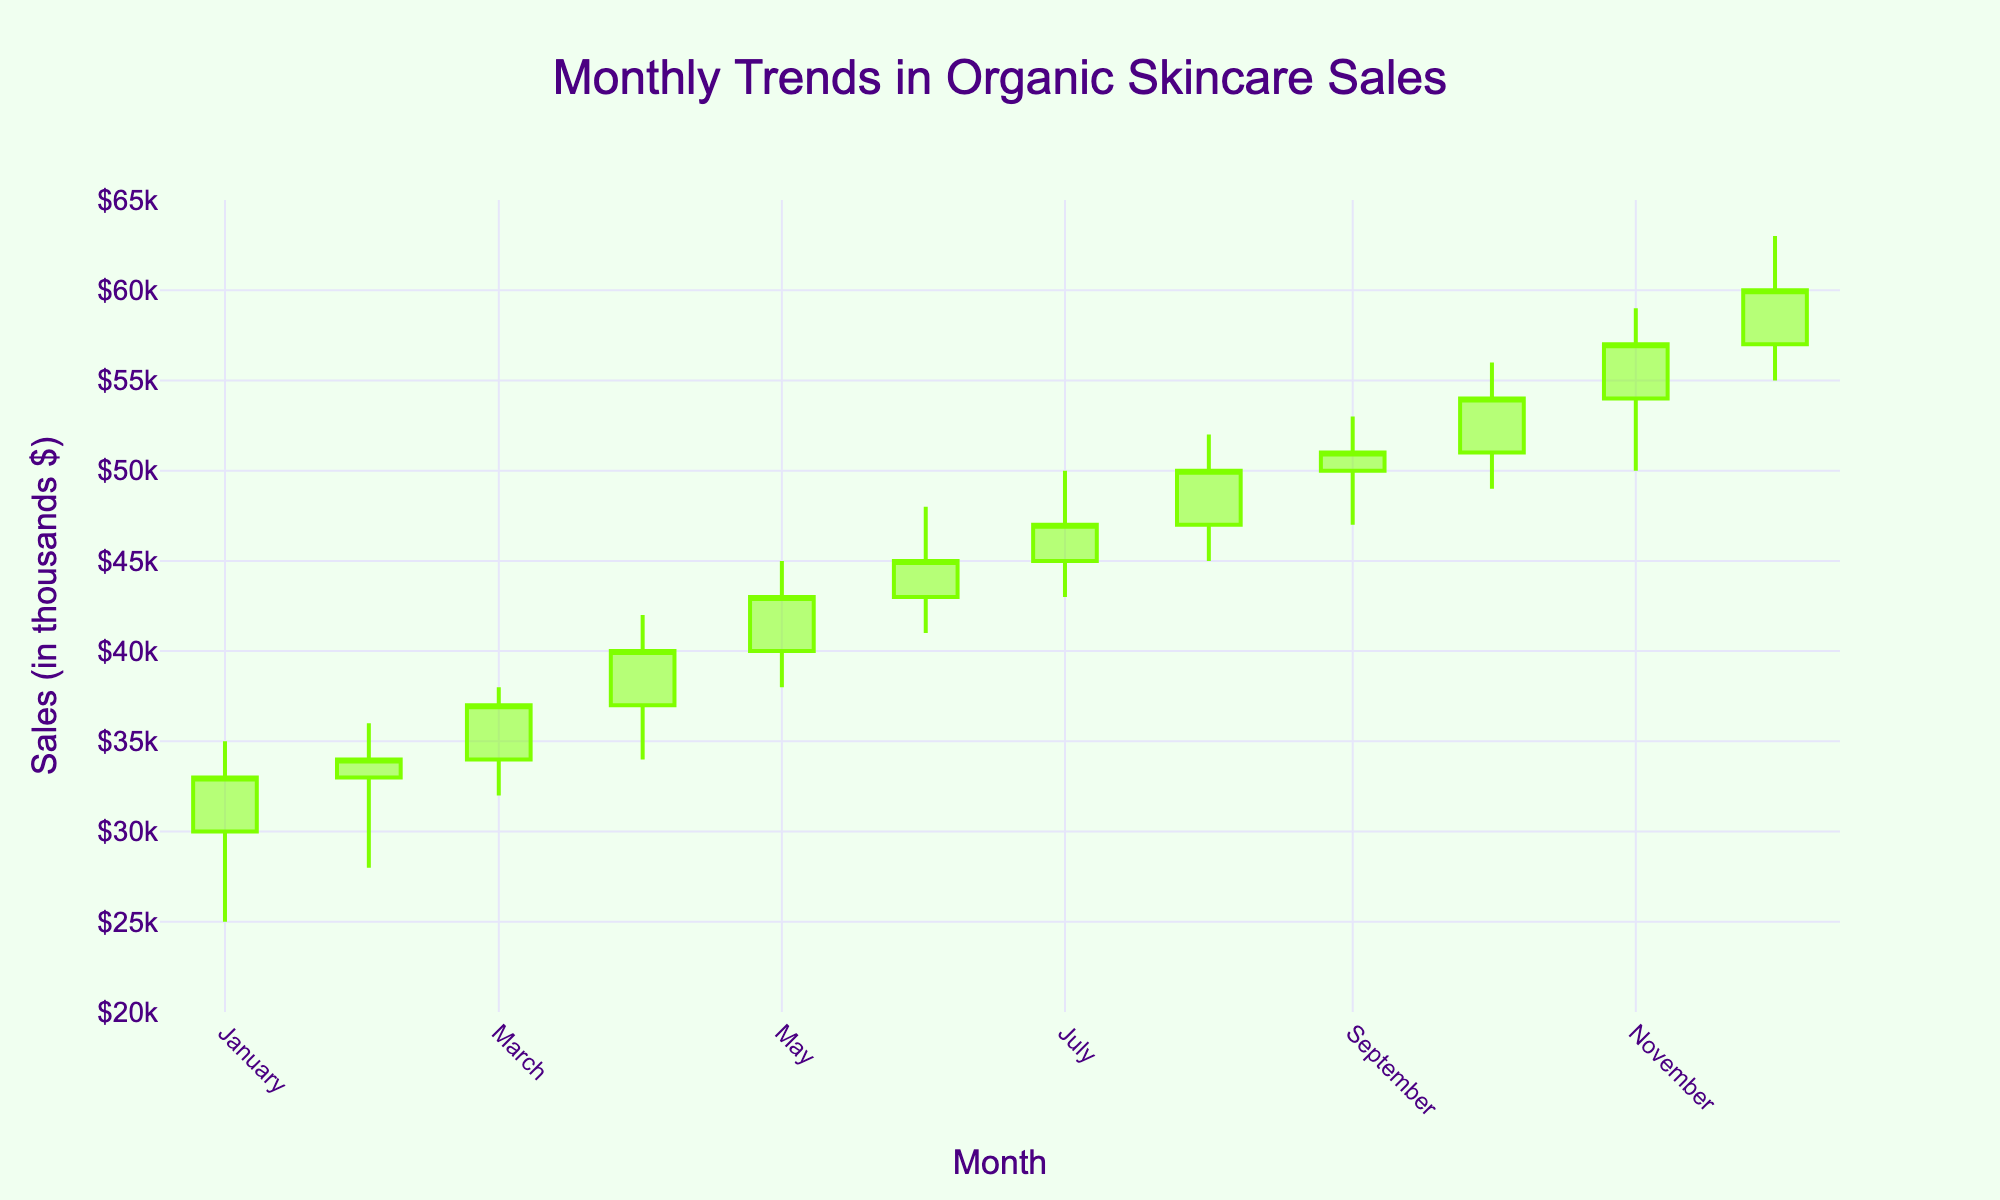what is the title of the plot? The title of the plot is located at the top center of the figure.
Answer: Monthly Trends in Organic Skincare Sales What is the highest sales value recorded? To find the highest sales value, look at the 'High' column and identify the maximum value, which is visually represented by the highest point of any candlestick bar.
Answer: $63k What is the lowest closing value and in which month did it occur? To determine the lowest closing value, look at the 'Close' values of each month and identify the minimum. January has the lowest closing value.
Answer: $33k in January What is the difference between the highest closing value and the lowest closing value? Calculate the difference by subtracting the lowest closing value from the highest closing value. The lowest is $33k and the highest is $60k. The difference is $60k - $33k.
Answer: $27k Which month shows the greatest increase in sales? To find the month with the greatest increase, look for the month where the difference between the 'Open' and 'Close' values is the largest. This occurs in December, where the open is $57k and the close is $60k.
Answer: December How does the closing value in July compare to that in January? Compare the closing values of both months: January's closing value is $33k and July's closing value is $47k. July is higher than January.
Answer: July is $14k higher than January Which months have more than a $5k difference between their opening and closing values? Identify the months where the absolute difference between 'Open' and 'Close' values exceeds $5k. These months are: January, April, November, and December.
Answer: January, April, November, and December What month had the largest difference between its high and low values? To identify this, find the month with the highest difference between 'High' and 'Low' values. December shows the largest difference with a high of $63k and a low of $55k.
Answer: December Is there a month where the closing value is exactly equal to the high value? Check if any month has a 'Close' value that matches its 'High' value. None of the months have this characteristic.
Answer: No Which color indicates a month where the closing value was higher than the opening value? Identify the color used for increasing months in the candlestick plot. The color for increasing months is chartreuse.
Answer: Chartreuse 